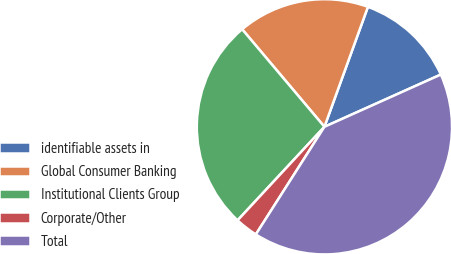Convert chart to OTSL. <chart><loc_0><loc_0><loc_500><loc_500><pie_chart><fcel>identifiable assets in<fcel>Global Consumer Banking<fcel>Institutional Clients Group<fcel>Corporate/Other<fcel>Total<nl><fcel>12.75%<fcel>16.69%<fcel>26.94%<fcel>2.88%<fcel>40.75%<nl></chart> 